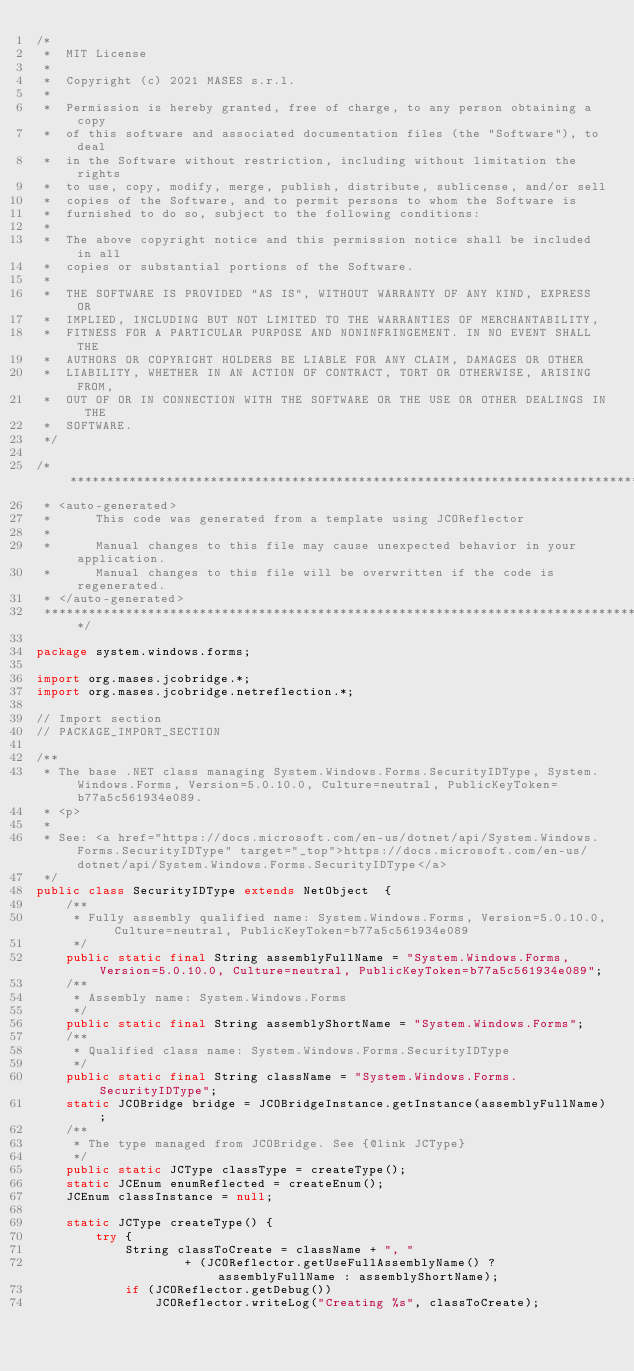<code> <loc_0><loc_0><loc_500><loc_500><_Java_>/*
 *  MIT License
 *
 *  Copyright (c) 2021 MASES s.r.l.
 *
 *  Permission is hereby granted, free of charge, to any person obtaining a copy
 *  of this software and associated documentation files (the "Software"), to deal
 *  in the Software without restriction, including without limitation the rights
 *  to use, copy, modify, merge, publish, distribute, sublicense, and/or sell
 *  copies of the Software, and to permit persons to whom the Software is
 *  furnished to do so, subject to the following conditions:
 *
 *  The above copyright notice and this permission notice shall be included in all
 *  copies or substantial portions of the Software.
 *
 *  THE SOFTWARE IS PROVIDED "AS IS", WITHOUT WARRANTY OF ANY KIND, EXPRESS OR
 *  IMPLIED, INCLUDING BUT NOT LIMITED TO THE WARRANTIES OF MERCHANTABILITY,
 *  FITNESS FOR A PARTICULAR PURPOSE AND NONINFRINGEMENT. IN NO EVENT SHALL THE
 *  AUTHORS OR COPYRIGHT HOLDERS BE LIABLE FOR ANY CLAIM, DAMAGES OR OTHER
 *  LIABILITY, WHETHER IN AN ACTION OF CONTRACT, TORT OR OTHERWISE, ARISING FROM,
 *  OUT OF OR IN CONNECTION WITH THE SOFTWARE OR THE USE OR OTHER DEALINGS IN THE
 *  SOFTWARE.
 */

/**************************************************************************************
 * <auto-generated>
 *      This code was generated from a template using JCOReflector
 * 
 *      Manual changes to this file may cause unexpected behavior in your application.
 *      Manual changes to this file will be overwritten if the code is regenerated.
 * </auto-generated>
 *************************************************************************************/

package system.windows.forms;

import org.mases.jcobridge.*;
import org.mases.jcobridge.netreflection.*;

// Import section
// PACKAGE_IMPORT_SECTION

/**
 * The base .NET class managing System.Windows.Forms.SecurityIDType, System.Windows.Forms, Version=5.0.10.0, Culture=neutral, PublicKeyToken=b77a5c561934e089.
 * <p>
 * 
 * See: <a href="https://docs.microsoft.com/en-us/dotnet/api/System.Windows.Forms.SecurityIDType" target="_top">https://docs.microsoft.com/en-us/dotnet/api/System.Windows.Forms.SecurityIDType</a>
 */
public class SecurityIDType extends NetObject  {
    /**
     * Fully assembly qualified name: System.Windows.Forms, Version=5.0.10.0, Culture=neutral, PublicKeyToken=b77a5c561934e089
     */
    public static final String assemblyFullName = "System.Windows.Forms, Version=5.0.10.0, Culture=neutral, PublicKeyToken=b77a5c561934e089";
    /**
     * Assembly name: System.Windows.Forms
     */
    public static final String assemblyShortName = "System.Windows.Forms";
    /**
     * Qualified class name: System.Windows.Forms.SecurityIDType
     */
    public static final String className = "System.Windows.Forms.SecurityIDType";
    static JCOBridge bridge = JCOBridgeInstance.getInstance(assemblyFullName);
    /**
     * The type managed from JCOBridge. See {@link JCType}
     */
    public static JCType classType = createType();
    static JCEnum enumReflected = createEnum();
    JCEnum classInstance = null;

    static JCType createType() {
        try {
            String classToCreate = className + ", "
                    + (JCOReflector.getUseFullAssemblyName() ? assemblyFullName : assemblyShortName);
            if (JCOReflector.getDebug())
                JCOReflector.writeLog("Creating %s", classToCreate);</code> 